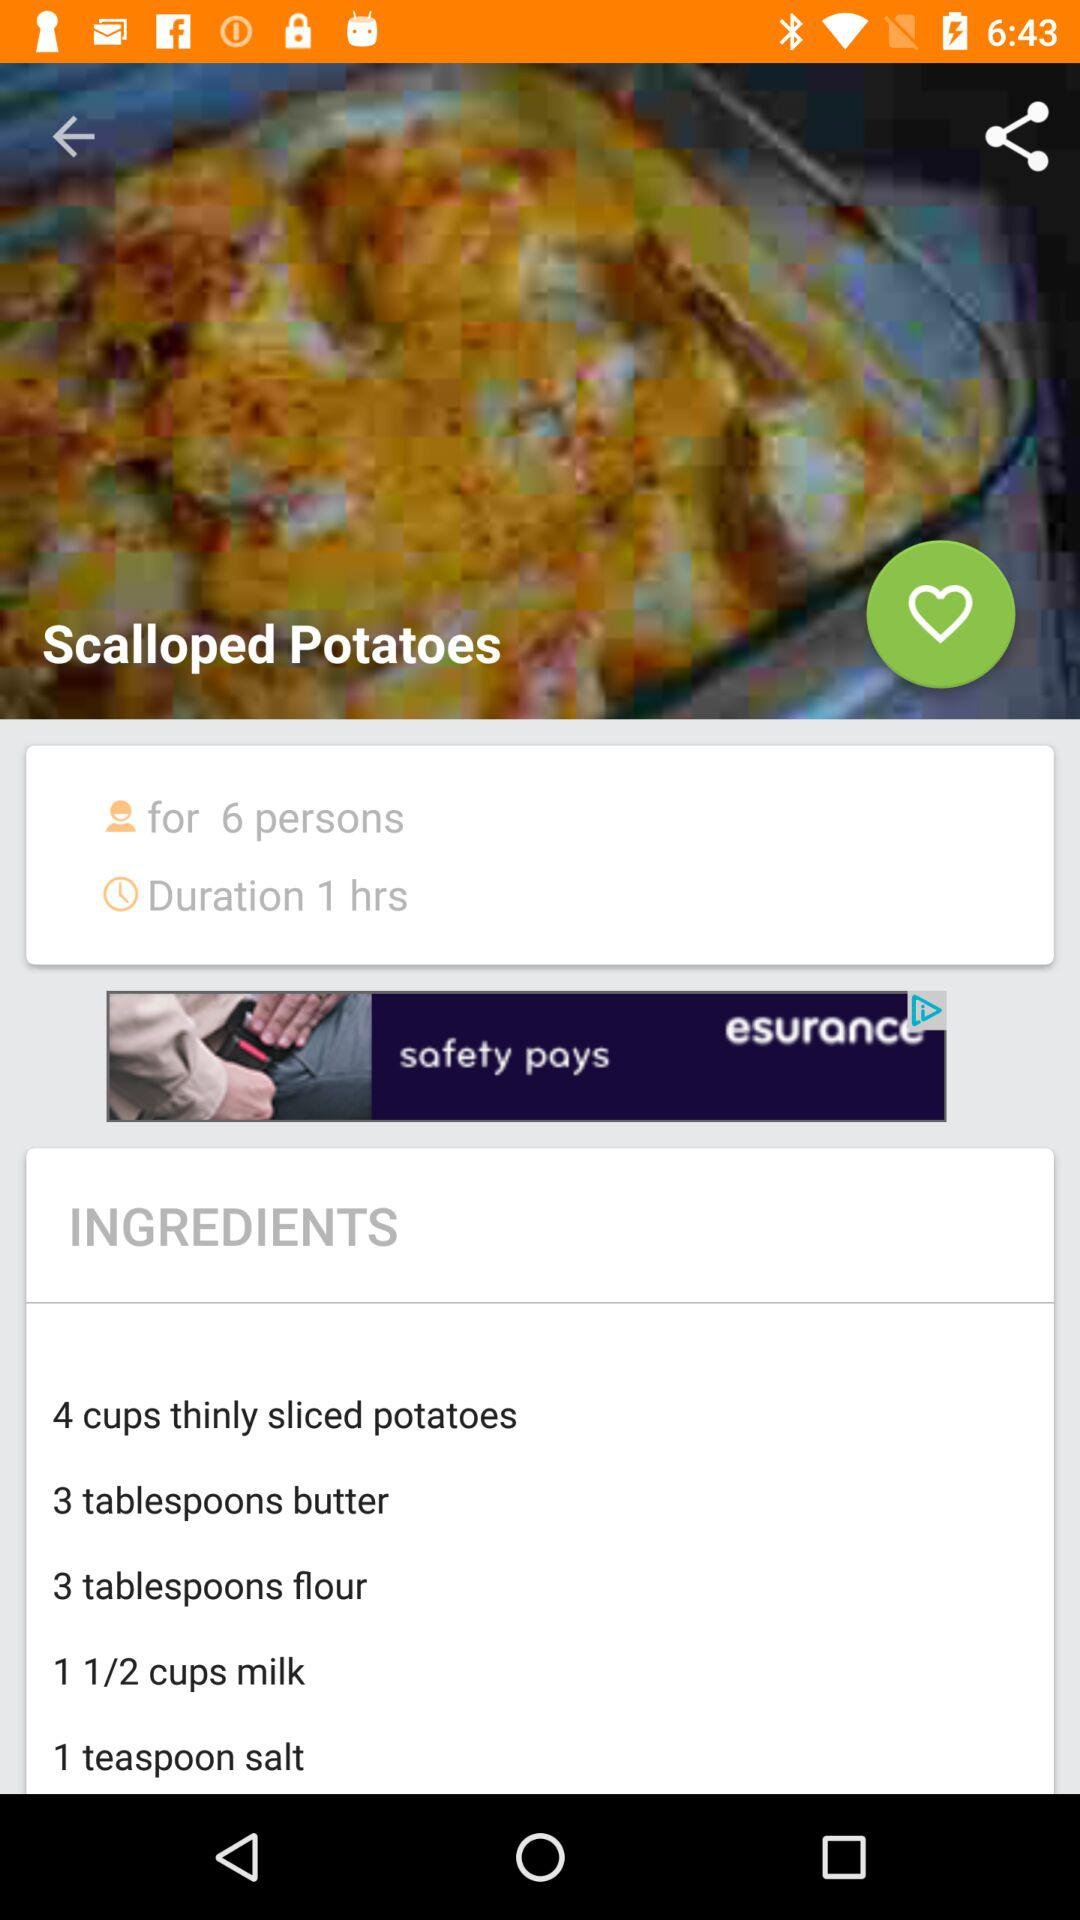How many tablespoons of butter are required to make "Scalloped Potatoes"? To make "Scalloped Potatoes", 3 tablespoons of butter are required. 